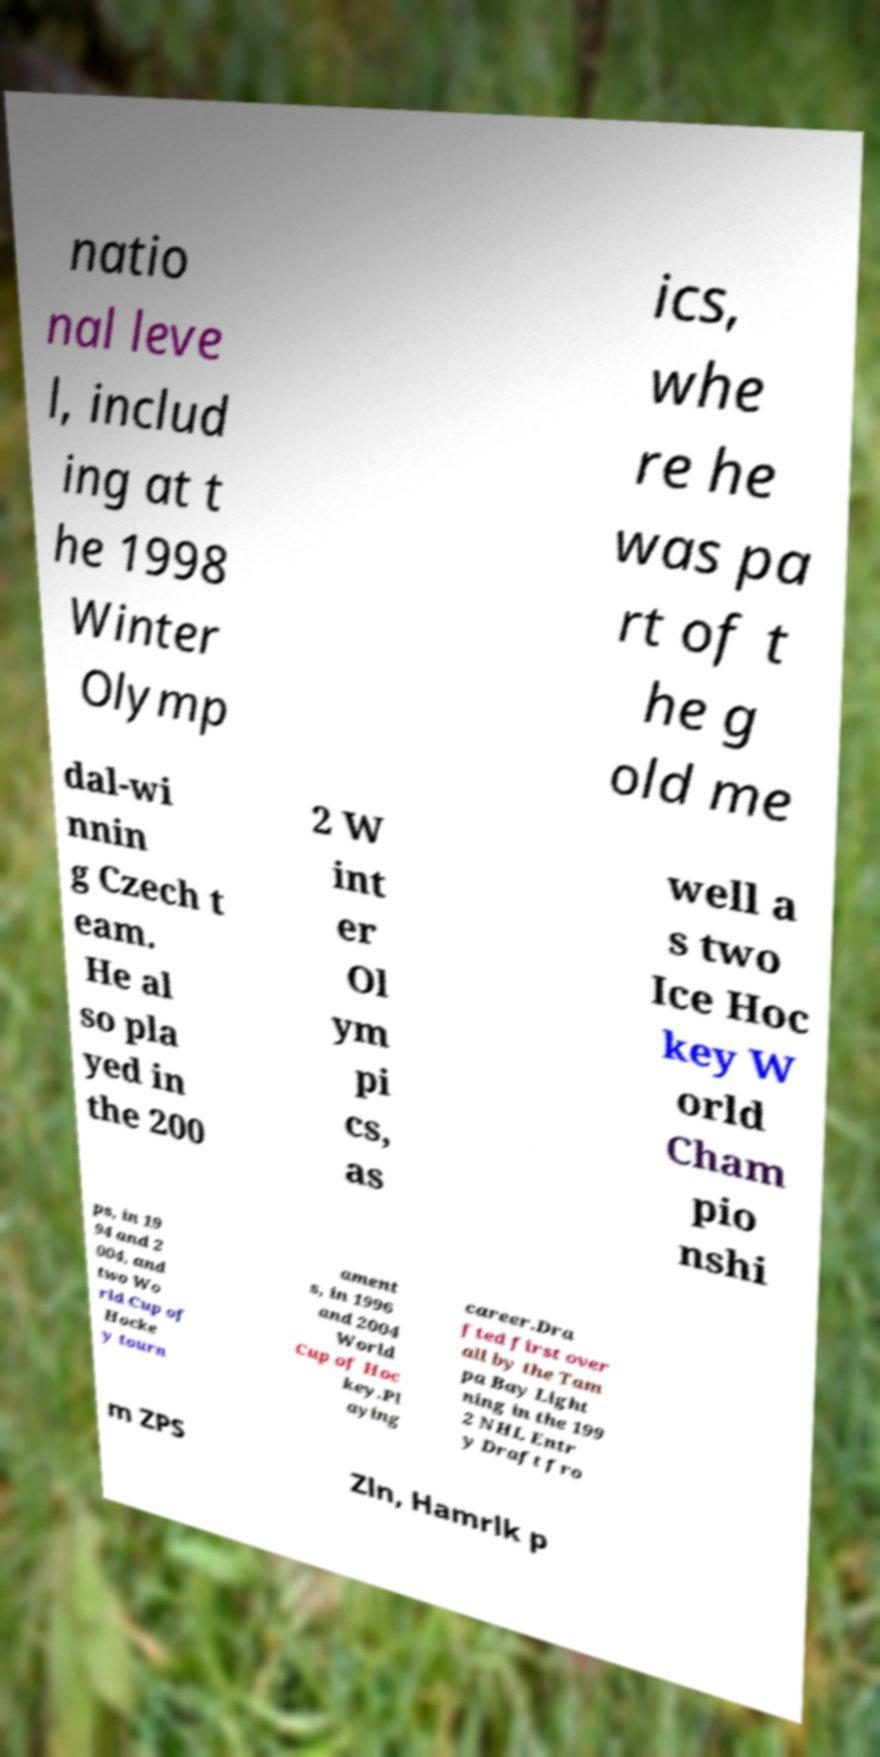Could you extract and type out the text from this image? natio nal leve l, includ ing at t he 1998 Winter Olymp ics, whe re he was pa rt of t he g old me dal-wi nnin g Czech t eam. He al so pla yed in the 200 2 W int er Ol ym pi cs, as well a s two Ice Hoc key W orld Cham pio nshi ps, in 19 94 and 2 004, and two Wo rld Cup of Hocke y tourn ament s, in 1996 and 2004 World Cup of Hoc key.Pl aying career.Dra fted first over all by the Tam pa Bay Light ning in the 199 2 NHL Entr y Draft fro m ZPS Zln, Hamrlk p 